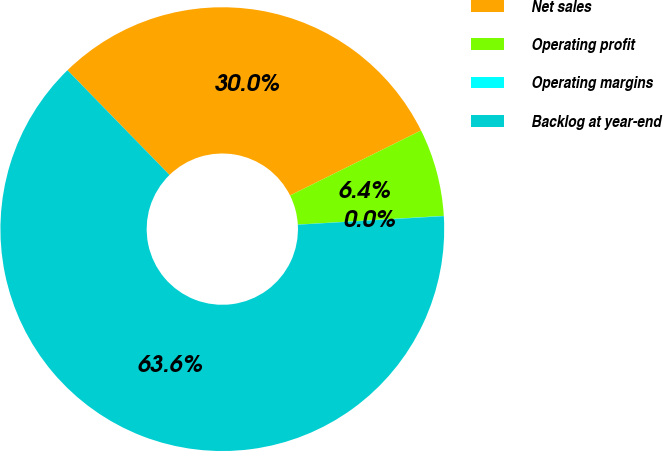Convert chart to OTSL. <chart><loc_0><loc_0><loc_500><loc_500><pie_chart><fcel>Net sales<fcel>Operating profit<fcel>Operating margins<fcel>Backlog at year-end<nl><fcel>29.96%<fcel>6.38%<fcel>0.02%<fcel>63.63%<nl></chart> 